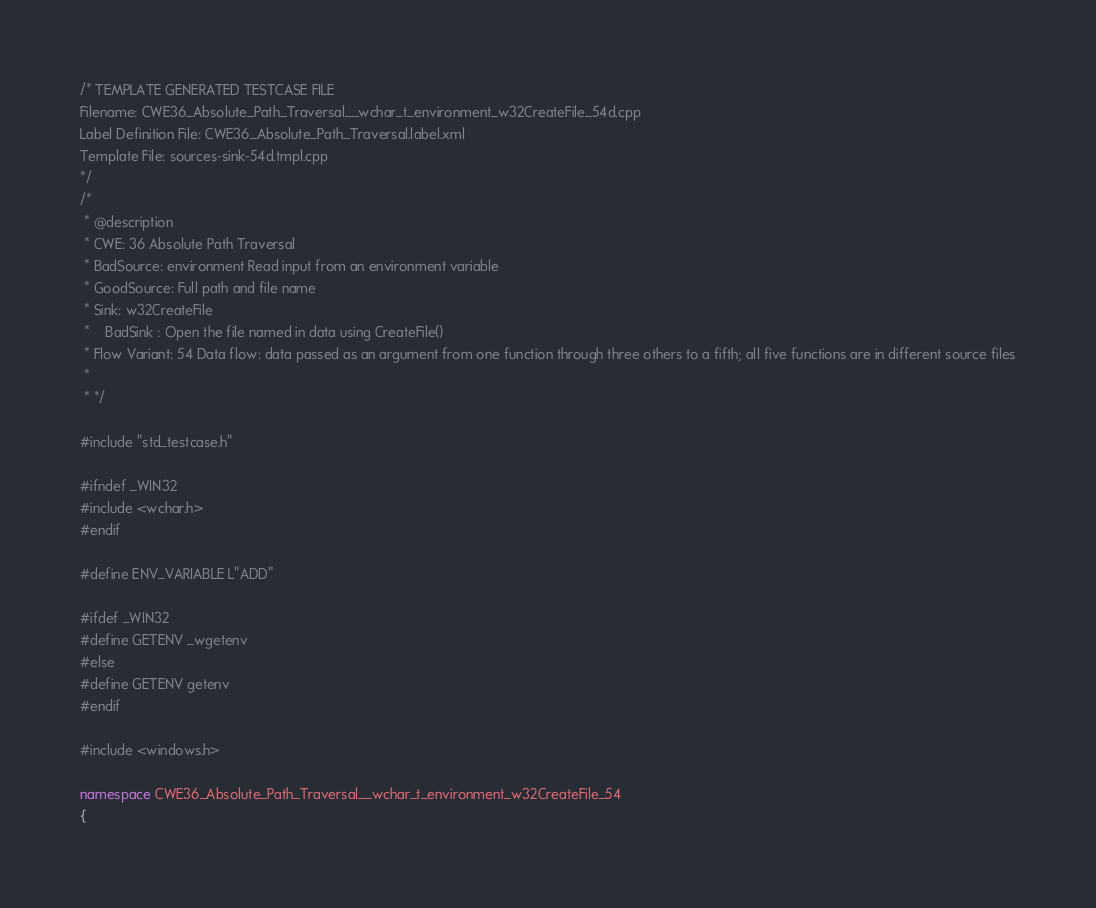<code> <loc_0><loc_0><loc_500><loc_500><_C++_>/* TEMPLATE GENERATED TESTCASE FILE
Filename: CWE36_Absolute_Path_Traversal__wchar_t_environment_w32CreateFile_54d.cpp
Label Definition File: CWE36_Absolute_Path_Traversal.label.xml
Template File: sources-sink-54d.tmpl.cpp
*/
/*
 * @description
 * CWE: 36 Absolute Path Traversal
 * BadSource: environment Read input from an environment variable
 * GoodSource: Full path and file name
 * Sink: w32CreateFile
 *    BadSink : Open the file named in data using CreateFile()
 * Flow Variant: 54 Data flow: data passed as an argument from one function through three others to a fifth; all five functions are in different source files
 *
 * */

#include "std_testcase.h"

#ifndef _WIN32
#include <wchar.h>
#endif

#define ENV_VARIABLE L"ADD"

#ifdef _WIN32
#define GETENV _wgetenv
#else
#define GETENV getenv
#endif

#include <windows.h>

namespace CWE36_Absolute_Path_Traversal__wchar_t_environment_w32CreateFile_54
{
</code> 